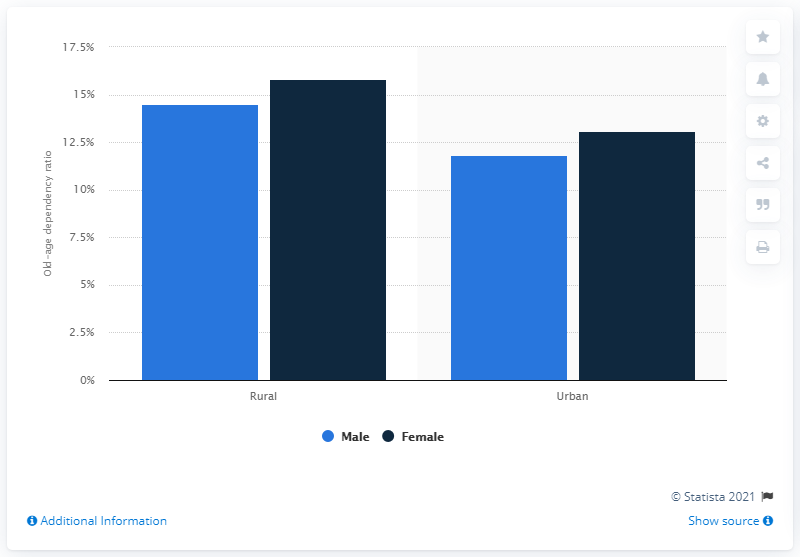Give some essential details in this illustration. According to the data from 2011, the ratio of females living in rural areas in India was 15.8. 